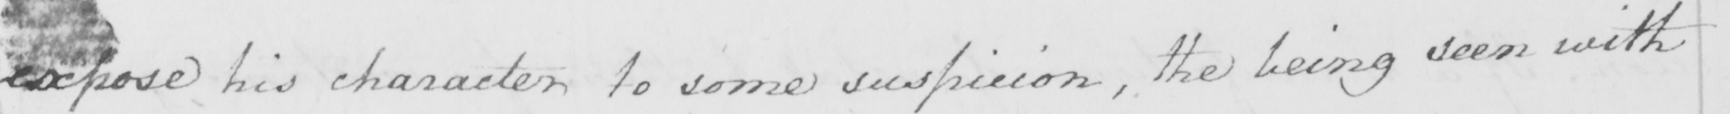Please transcribe the handwritten text in this image. expose his character to some suspicion , the being seen with 